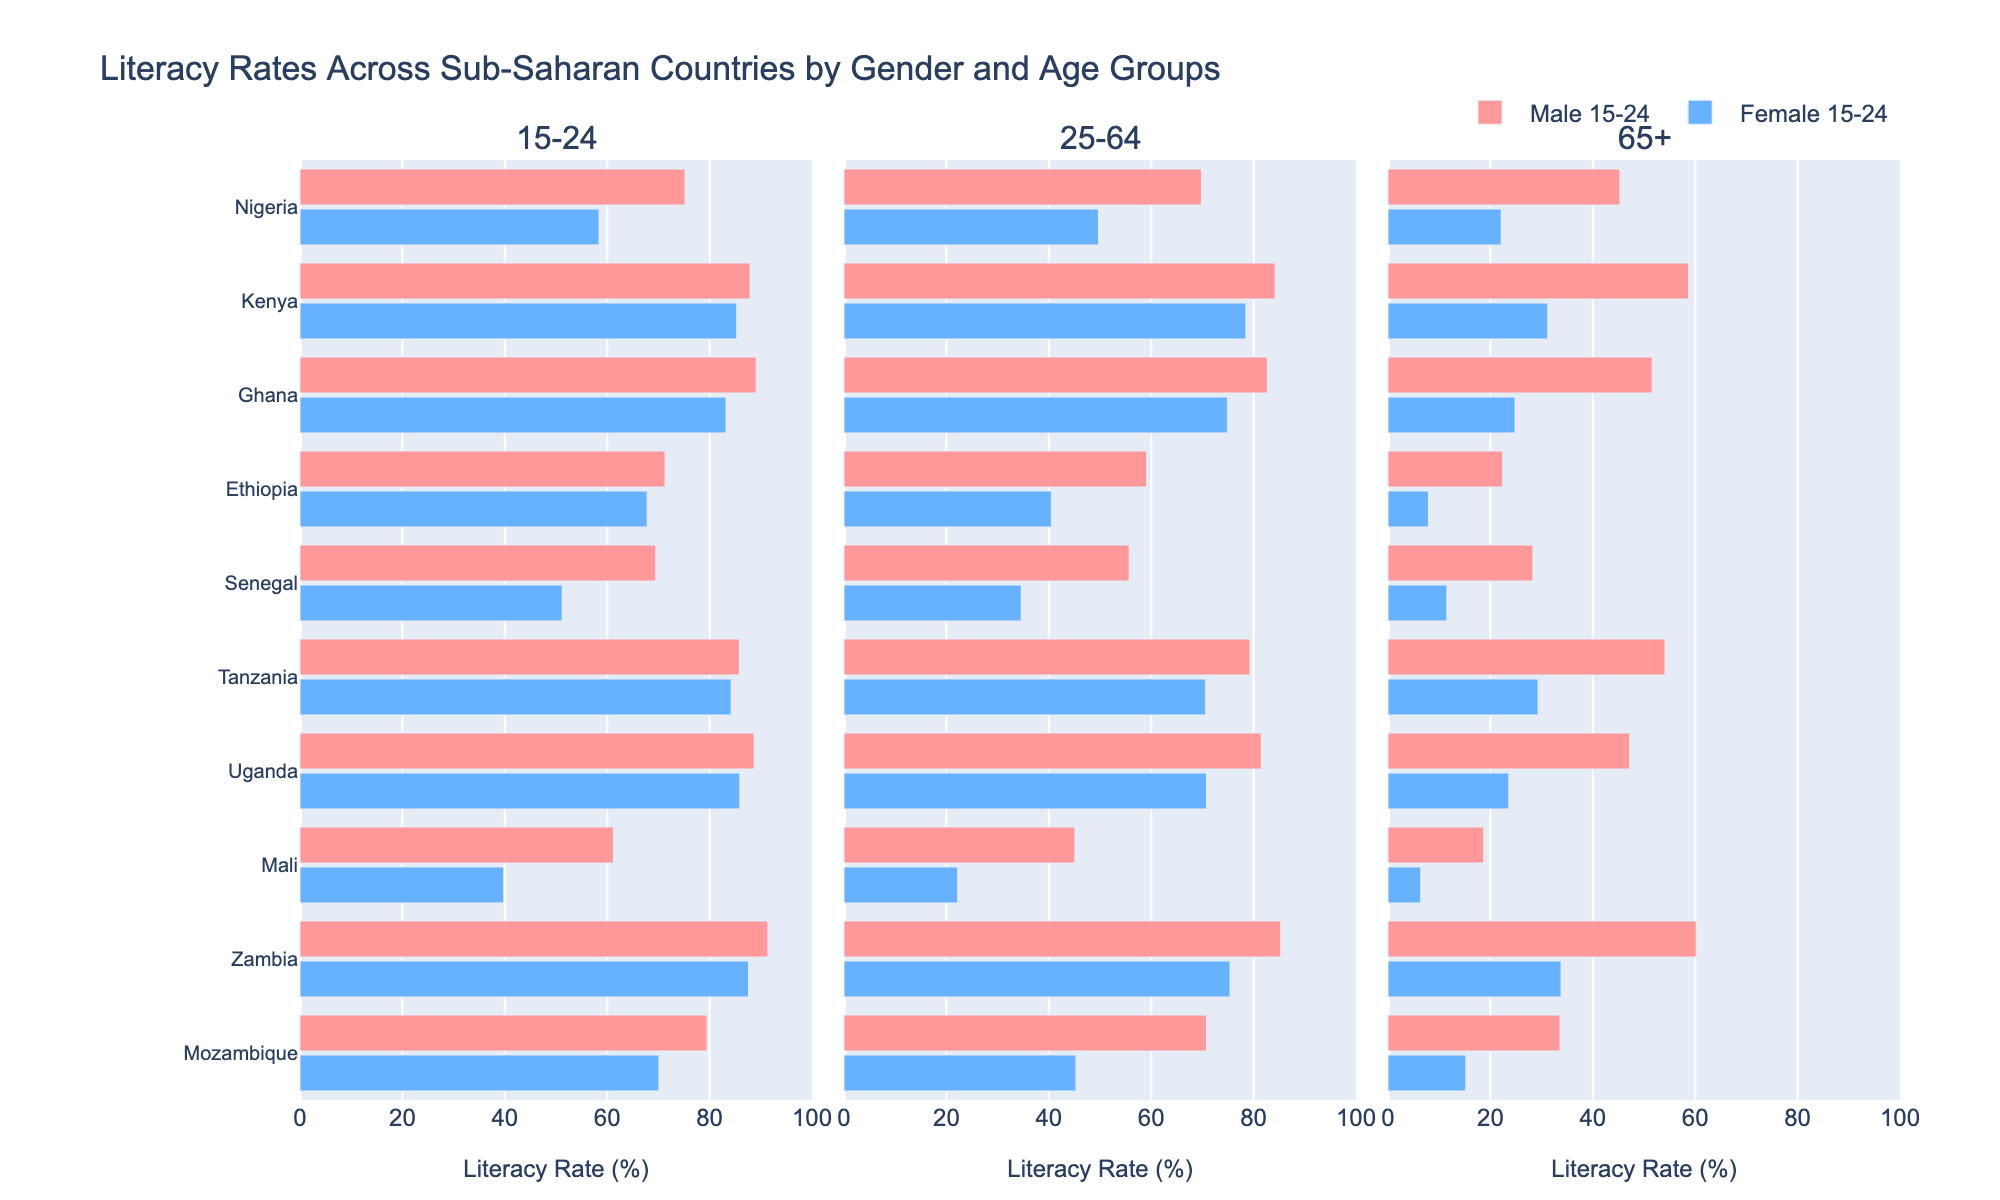Which country has the highest literacy rate for females aged 15-24? To answer this, look at the bar representing Female 15-24 in each subplot. The longest bar belongs to Zambia.
Answer: Zambia What is the difference in literacy rates between males and females aged 25-64 in Mozambique? Locate Mozambique's bars for Male 25-64 and Female 25-64 in the second subplot. Subtract the Female value (45.3) from the Male value (70.8): 70.8 - 45.3 = 25.5
Answer: 25.5 Which age group shows the biggest gender literacy gap in Mali? Examine the three subplots for Mali’s bars. The largest difference is in the 25-64 age group, where Male is 45.1 and Female is 22.2.
Answer: 25-64 How does Nigeria's literacy rate for males aged 65+ compare to females 15-24 in the same country? In the first subplot, locate Nigeria's female 15-24 bar (58.4) and in the third subplot, locate males 65+ bar (45.3). 45.3 < 58.4.
Answer: Less than What is the total literacy rate for both genders in Ghana aged 15-24? Add the Male 15-24 (89.1) and Female 15-24 (83.2) values: 89.1 + 83.2 = 172.3
Answer: 172.3 Which country shows the smallest gender gap in literacy rates for the 65+ age group? Compare the differences between Male 65+ and Female 65+ for all countries in the third subplot. Kenya has the smallest gap: Male 58.7, Female 31.2; Difference = 27.5
Answer: Kenya What is the average literacy rate for females aged 25-64 across all countries? Sum the Female 25-64 rates and divide by the number of countries: (49.7 + 78.5 + 74.9 + 40.5 + 34.6 + 70.6 + 70.8 + 22.2 + 75.4 + 45.3) / 10 = 56.25
Answer: 56.25 In which country is the literacy rate for males aged 25-64 higher than the literacy rate for females aged 15-24 by more than 10%? Compare the rates for each country: Males 25-64 and Females 15-24. Mozambique (70.8) Male - (70.1) Female = 0.7; Ghana (82.7) Male - (83.2) Female = -0.5; correct for: Nigeria (69.8) Male - (58.4) Female = 11.4
Answer: Nigeria, Mozambique, Ethiopia, Senegal Which country has the closest literacy rates between males aged 15-24 and males aged 25-64? Review the bars for males aged 15-24 and 25-64 in each country. Zambia's bars are closest (91.4 vs 85.3).
Answer: Zambia 